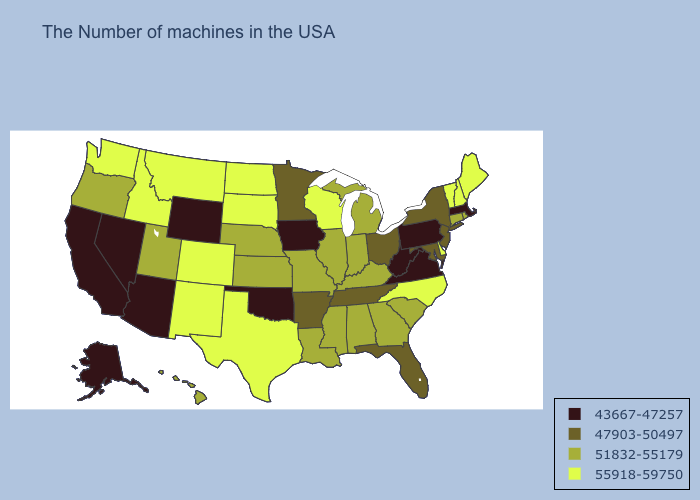What is the value of Missouri?
Answer briefly. 51832-55179. Among the states that border Massachusetts , does Vermont have the highest value?
Write a very short answer. Yes. Does Nebraska have the lowest value in the USA?
Concise answer only. No. Among the states that border Idaho , does Utah have the highest value?
Write a very short answer. No. Name the states that have a value in the range 55918-59750?
Give a very brief answer. Maine, New Hampshire, Vermont, Delaware, North Carolina, Wisconsin, Texas, South Dakota, North Dakota, Colorado, New Mexico, Montana, Idaho, Washington. What is the value of Mississippi?
Concise answer only. 51832-55179. Name the states that have a value in the range 51832-55179?
Give a very brief answer. Rhode Island, Connecticut, South Carolina, Georgia, Michigan, Kentucky, Indiana, Alabama, Illinois, Mississippi, Louisiana, Missouri, Kansas, Nebraska, Utah, Oregon, Hawaii. What is the highest value in states that border Arkansas?
Be succinct. 55918-59750. Which states have the lowest value in the West?
Be succinct. Wyoming, Arizona, Nevada, California, Alaska. Does the first symbol in the legend represent the smallest category?
Write a very short answer. Yes. Name the states that have a value in the range 47903-50497?
Be succinct. New York, New Jersey, Maryland, Ohio, Florida, Tennessee, Arkansas, Minnesota. What is the value of Massachusetts?
Quick response, please. 43667-47257. What is the highest value in states that border Michigan?
Concise answer only. 55918-59750. What is the lowest value in the USA?
Write a very short answer. 43667-47257. Among the states that border Louisiana , which have the lowest value?
Answer briefly. Arkansas. 